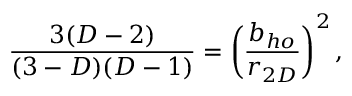<formula> <loc_0><loc_0><loc_500><loc_500>\frac { 3 ( D - 2 ) } { ( 3 - D ) ( D - 1 ) } = \left ( \frac { b _ { h o } } { r _ { 2 D } } \right ) ^ { 2 } ,</formula> 